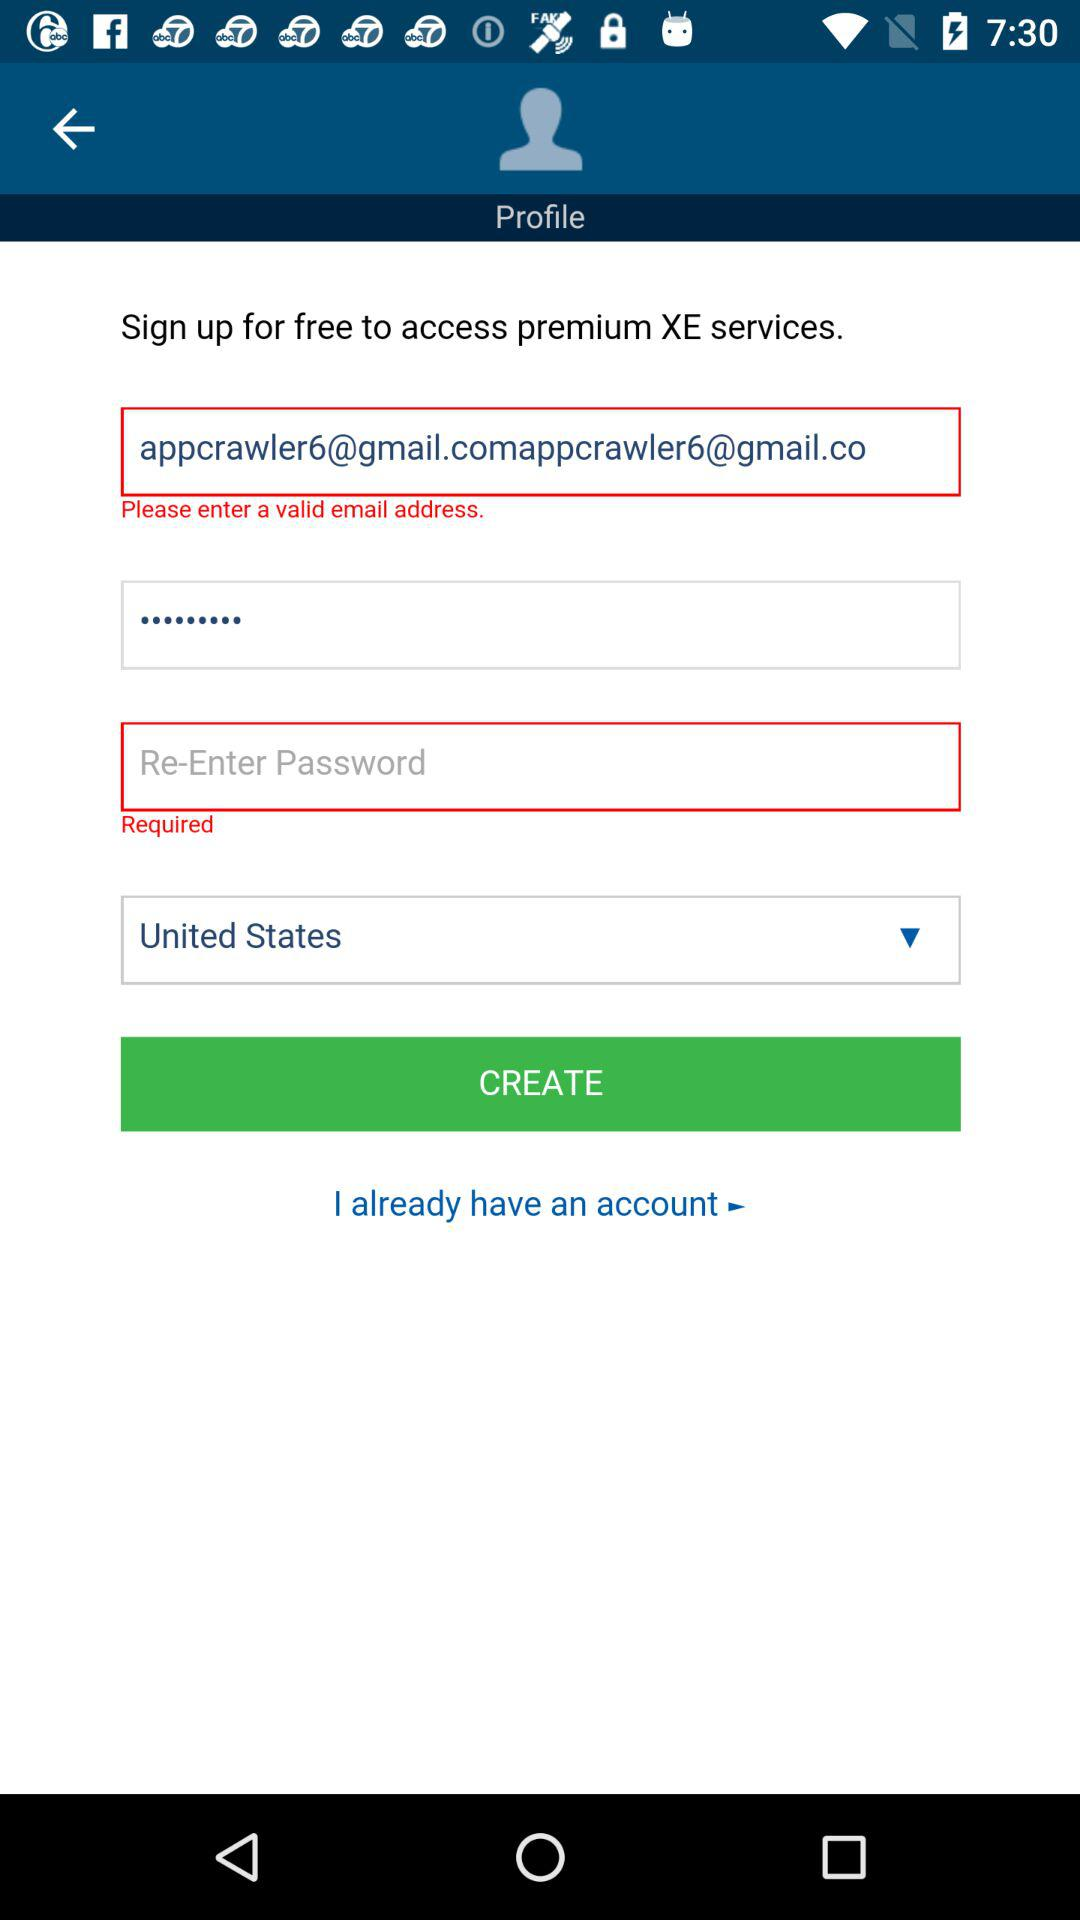How many text fields are there in the sign up form?
Answer the question using a single word or phrase. 3 